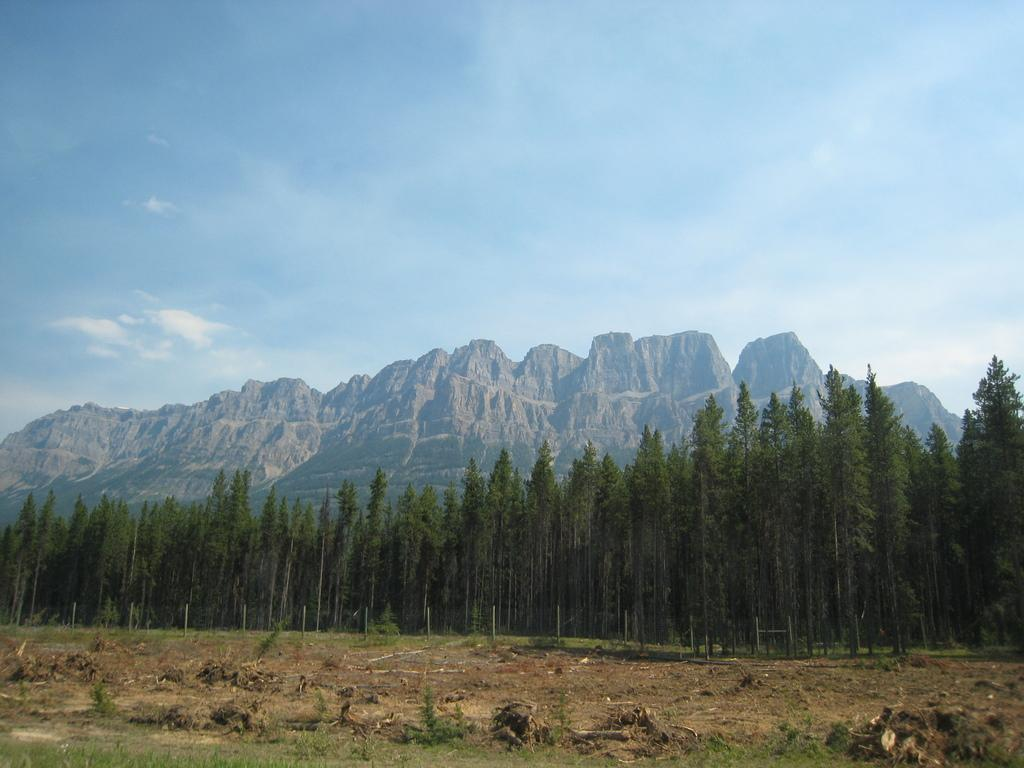What is the main setting of the image? There is a field in the image. What can be seen in the background of the field? There is fencing, trees, a mountain, and a blue sky in the background of the image. Where is the kettle located in the image? There is no kettle present in the image. What type of copy machine can be seen in the image? There is no copy machine present in the image. What type of ocean can be seen in the image? There is no ocean present in the image. 